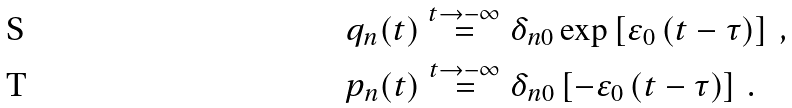Convert formula to latex. <formula><loc_0><loc_0><loc_500><loc_500>& q _ { n } ( t ) \overset { t \rightarrow - \infty } { = } \delta _ { n 0 } \exp \left [ \varepsilon _ { 0 } \left ( t - \tau \right ) \right ] \, , \\ & p _ { n } ( t ) \overset { t \rightarrow - \infty } { = } \delta _ { n 0 } \left [ - \varepsilon _ { 0 } \left ( t - \tau \right ) \right ] \, .</formula> 